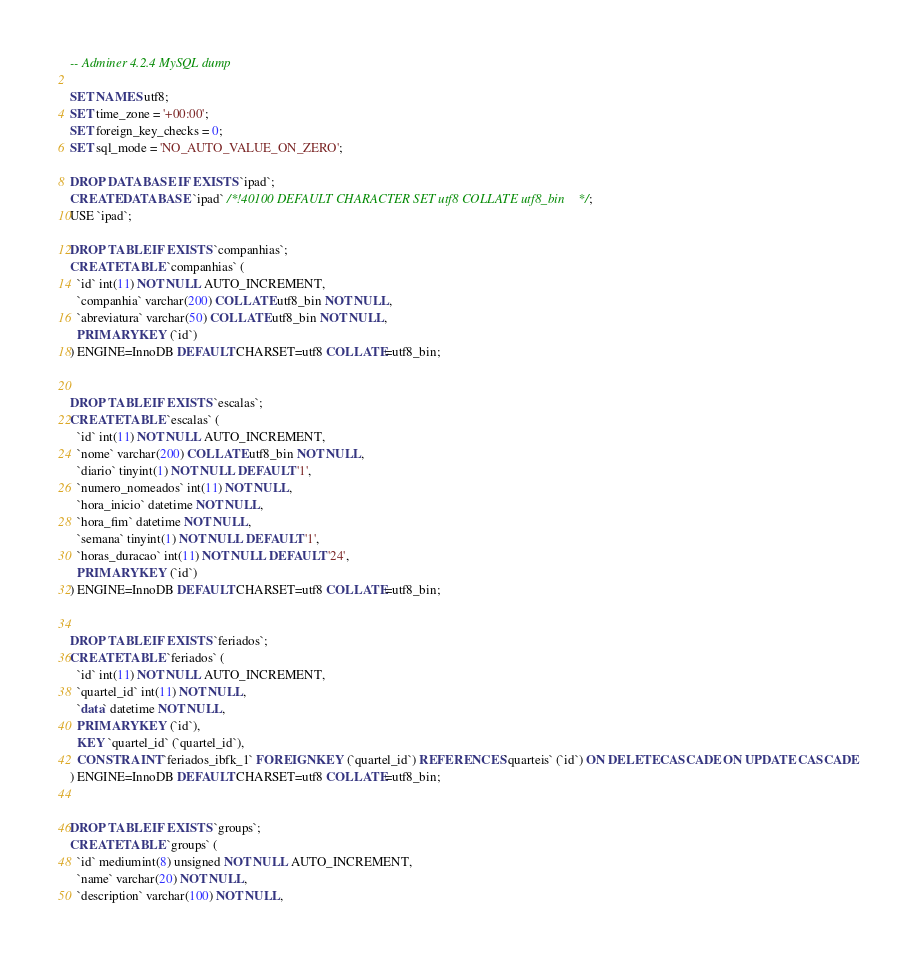<code> <loc_0><loc_0><loc_500><loc_500><_SQL_>-- Adminer 4.2.4 MySQL dump

SET NAMES utf8;
SET time_zone = '+00:00';
SET foreign_key_checks = 0;
SET sql_mode = 'NO_AUTO_VALUE_ON_ZERO';

DROP DATABASE IF EXISTS `ipad`;
CREATE DATABASE `ipad` /*!40100 DEFAULT CHARACTER SET utf8 COLLATE utf8_bin */;
USE `ipad`;

DROP TABLE IF EXISTS `companhias`;
CREATE TABLE `companhias` (
  `id` int(11) NOT NULL AUTO_INCREMENT,
  `companhia` varchar(200) COLLATE utf8_bin NOT NULL,
  `abreviatura` varchar(50) COLLATE utf8_bin NOT NULL,
  PRIMARY KEY (`id`)
) ENGINE=InnoDB DEFAULT CHARSET=utf8 COLLATE=utf8_bin;


DROP TABLE IF EXISTS `escalas`;
CREATE TABLE `escalas` (
  `id` int(11) NOT NULL AUTO_INCREMENT,
  `nome` varchar(200) COLLATE utf8_bin NOT NULL,
  `diario` tinyint(1) NOT NULL DEFAULT '1',
  `numero_nomeados` int(11) NOT NULL,
  `hora_inicio` datetime NOT NULL,
  `hora_fim` datetime NOT NULL,
  `semana` tinyint(1) NOT NULL DEFAULT '1',
  `horas_duracao` int(11) NOT NULL DEFAULT '24',
  PRIMARY KEY (`id`)
) ENGINE=InnoDB DEFAULT CHARSET=utf8 COLLATE=utf8_bin;


DROP TABLE IF EXISTS `feriados`;
CREATE TABLE `feriados` (
  `id` int(11) NOT NULL AUTO_INCREMENT,
  `quartel_id` int(11) NOT NULL,
  `data` datetime NOT NULL,
  PRIMARY KEY (`id`),
  KEY `quartel_id` (`quartel_id`),
  CONSTRAINT `feriados_ibfk_1` FOREIGN KEY (`quartel_id`) REFERENCES `quarteis` (`id`) ON DELETE CASCADE ON UPDATE CASCADE
) ENGINE=InnoDB DEFAULT CHARSET=utf8 COLLATE=utf8_bin;


DROP TABLE IF EXISTS `groups`;
CREATE TABLE `groups` (
  `id` mediumint(8) unsigned NOT NULL AUTO_INCREMENT,
  `name` varchar(20) NOT NULL,
  `description` varchar(100) NOT NULL,</code> 